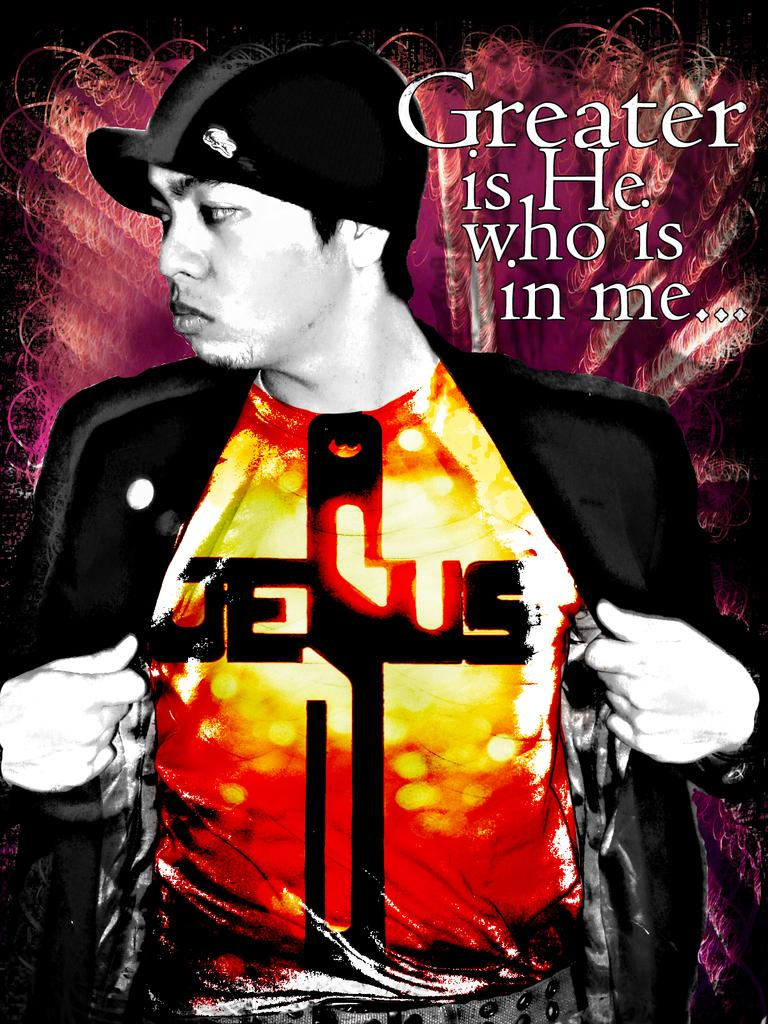<image>
Describe the image concisely. Man showing his shirt which says the word Jesus. 